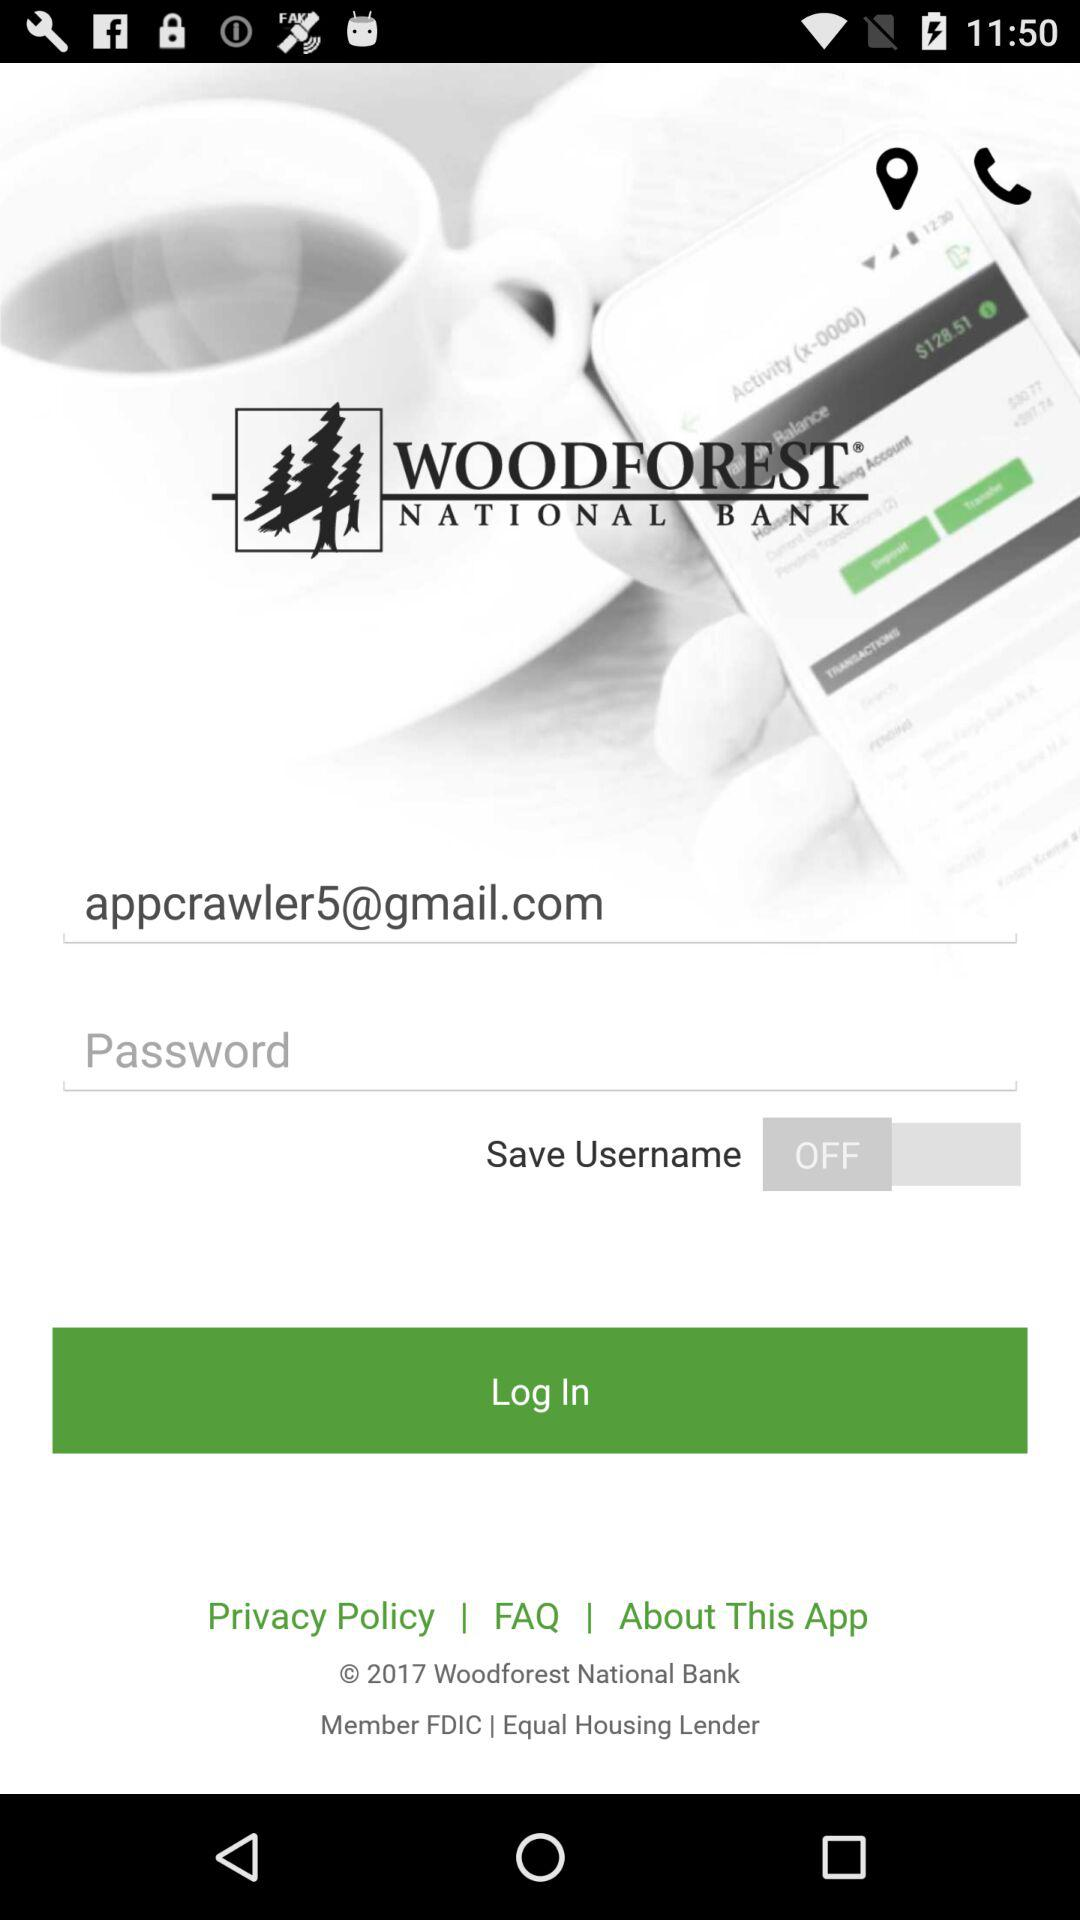What is the email address? The email address is appcrawler5@gmail.com. 